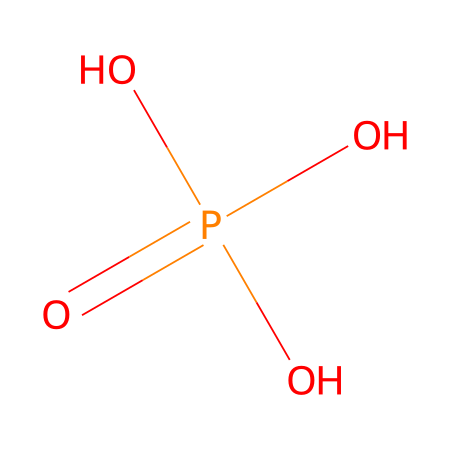What is the total number of oxygen atoms in this compound? The SMILES representation shows four oxygen atoms connected to a phosphorus atom. Each "O" represents one oxygen atom, and there are three "O" atoms in the phosphate groups plus one that is double bonded to phosphorus.
Answer: four How many hydrogen atoms are present in phosphoric acid? In the structure, three hydrogen atoms are indicated by the three "O" atoms that are single bonded to phosphorus, which typically forms one bond with a hydrogen atom each in this acid.
Answer: three What is the central atom in phosphoric acid? The structure is centered around phosphorus, which is represented by the "P" in the SMILES notation. Phosphorus acts as the core element to which oxygen atoms are bonded.
Answer: phosphorus What type of compound is phosphoric acid classified as? This is a phosphoric acid, which falls under the category of oxyacids due to the presence of oxygen in its molecular structure along with hydrogen.
Answer: oxyacid Which element in the structure usually determines acidity? The hydrogen atoms in the structure are typically responsible for the acidic properties, as they can dissociate in aqueous solutions.
Answer: hydrogen How many double bonds are present in the molecular structure? The SMILES notation indicates one double bond between phosphorus and one oxygen atom, which is crucial for the acidic character of phosphoric acid.
Answer: one 